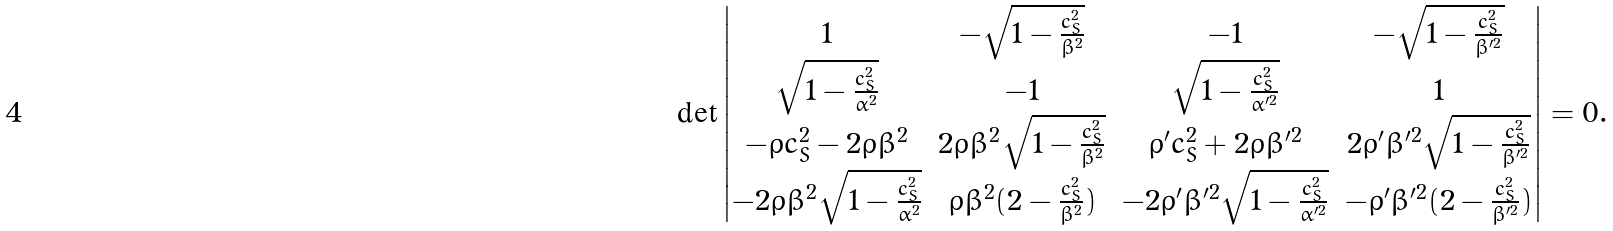<formula> <loc_0><loc_0><loc_500><loc_500>\det \begin{vmatrix} 1 & - \sqrt { 1 - \frac { c _ { S } ^ { 2 } } { \beta ^ { 2 } } } & - 1 & - \sqrt { 1 - \frac { c _ { S } ^ { 2 } } { \beta ^ { \prime 2 } } } \\ \sqrt { 1 - \frac { c _ { S } ^ { 2 } } { \alpha ^ { 2 } } } & - 1 & \sqrt { 1 - \frac { c _ { S } ^ { 2 } } { \alpha ^ { \prime 2 } } } & 1 \\ - \rho c _ { S } ^ { 2 } - 2 \rho \beta ^ { 2 } & 2 \rho \beta ^ { 2 } \sqrt { 1 - \frac { c _ { S } ^ { 2 } } { \beta ^ { 2 } } } & \rho ^ { \prime } c _ { S } ^ { 2 } + 2 \rho \beta ^ { \prime 2 } & 2 \rho ^ { \prime } \beta ^ { \prime 2 } \sqrt { 1 - \frac { c _ { S } ^ { 2 } } { \beta ^ { \prime 2 } } } \\ - 2 \rho \beta ^ { 2 } \sqrt { 1 - \frac { c _ { S } ^ { 2 } } { \alpha ^ { 2 } } } & \rho \beta ^ { 2 } ( 2 - \frac { c _ { S } ^ { 2 } } { \beta ^ { 2 } } ) & - 2 \rho ^ { \prime } \beta ^ { \prime 2 } \sqrt { 1 - \frac { c _ { S } ^ { 2 } } { \alpha ^ { \prime 2 } } } & - \rho ^ { \prime } \beta ^ { \prime 2 } ( 2 - \frac { c _ { S } ^ { 2 } } { \beta ^ { \prime 2 } } ) \end{vmatrix} = 0 .</formula> 